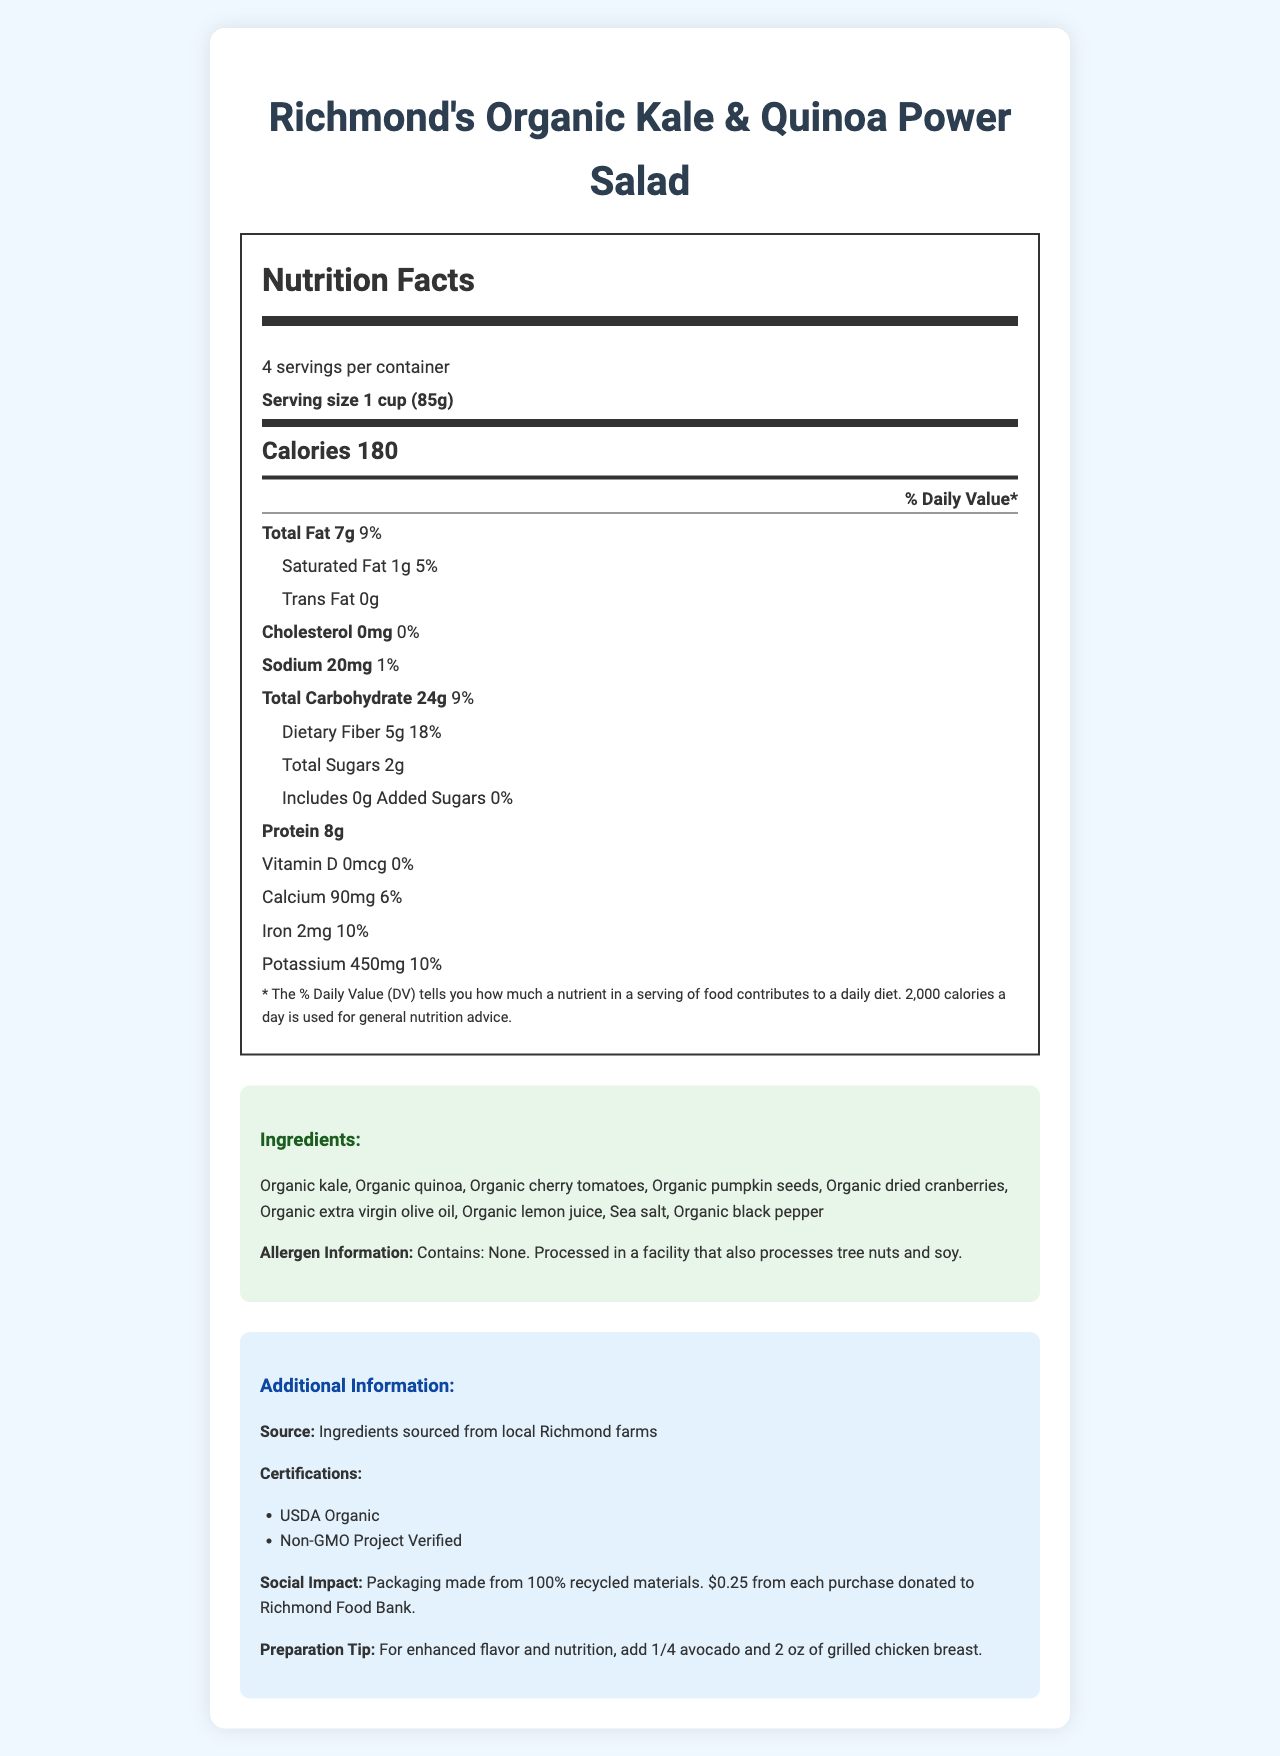what is the serving size for Richmond's Organic Kale & Quinoa Power Salad? The serving size is listed as "1 cup (85g)" in the Nutrition Facts section of the document.
Answer: 1 cup (85g) how many grams of dietary fiber are in one serving? The Nutrition Facts section states that one serving contains 5g of dietary fiber.
Answer: 5g what is the percentage of daily value for protein in this salad mix? The protein content is 8g, which is typically calculated as 16% of the daily value based on a 2,000 calorie diet.
Answer: 16% how many servings are in one container of this salad mix? The document mentions that there are 4 servings per container.
Answer: 4 list the vitamins and minerals contained in this salad with their respective daily values. The vitamins and minerals with their daily values are listed in the Nutrition Facts section.
Answer: Vitamin D: 0%, Calcium: 6%, Iron: 10%, Potassium: 10% which of the following ingredients is NOT in Richmond's Organic Kale & Quinoa Power Salad? A. Organic cherry tomatoes B. Organic cucumber C. Organic pumpkin seeds D. Organic dried cranberries The ingredients list does not include "Organic cucumber"; it lists other ingredients including Organic cherry tomatoes, Organic pumpkin seeds, and Organic dried cranberries.
Answer: B. Organic cucumber the salad mix contains: A. 2g of total sugars B. 7g of total sugar C. 5g of total sugar D. 9g of total sugar The Nutrition Facts section lists 2g of total sugars per serving.
Answer: A. 2g of total sugars is there any cholesterol in this salad mix? The document shows that the cholesterol content is 0mg, which is 0% of the daily value.
Answer: No summarize the main nutritional benefits and additional information provided on the document. The summary covers key points including nutritional content, ingredient sourcing, certifications, social impact, and preparation tips.
Answer: The salad mix is high in protein (8g) and dietary fiber (5g), and low in total sugars (2g). It's made from locally-sourced organic ingredients and is USDA Organic and Non-GMO Project Verified. Packaging is eco-friendly, and a portion of sales supports the Richmond Food Bank. A preparation tip suggests adding avocado and grilled chicken for extra nutrition. how much trans fat is in one serving of the salad mix? The Nutrition Facts section clearly states that there is 0g of trans fat per serving.
Answer: 0g where are the ingredients for this salad mix sourced from? The additional information section states that the ingredients are sourced from local Richmond farms.
Answer: Local Richmond farms can we determine the exact amount of Vitamin C in this salad mix from the document? The document does not provide information on the Vitamin C content.
Answer: Cannot be determined what is the preparation tip for enhancing flavor and nutrition mentioned in the document? The additional information section suggests enhancing flavor and nutrition by adding 1/4 avocado and 2 oz of grilled chicken breast.
Answer: Add 1/4 avocado and 2 oz of grilled chicken breast. 